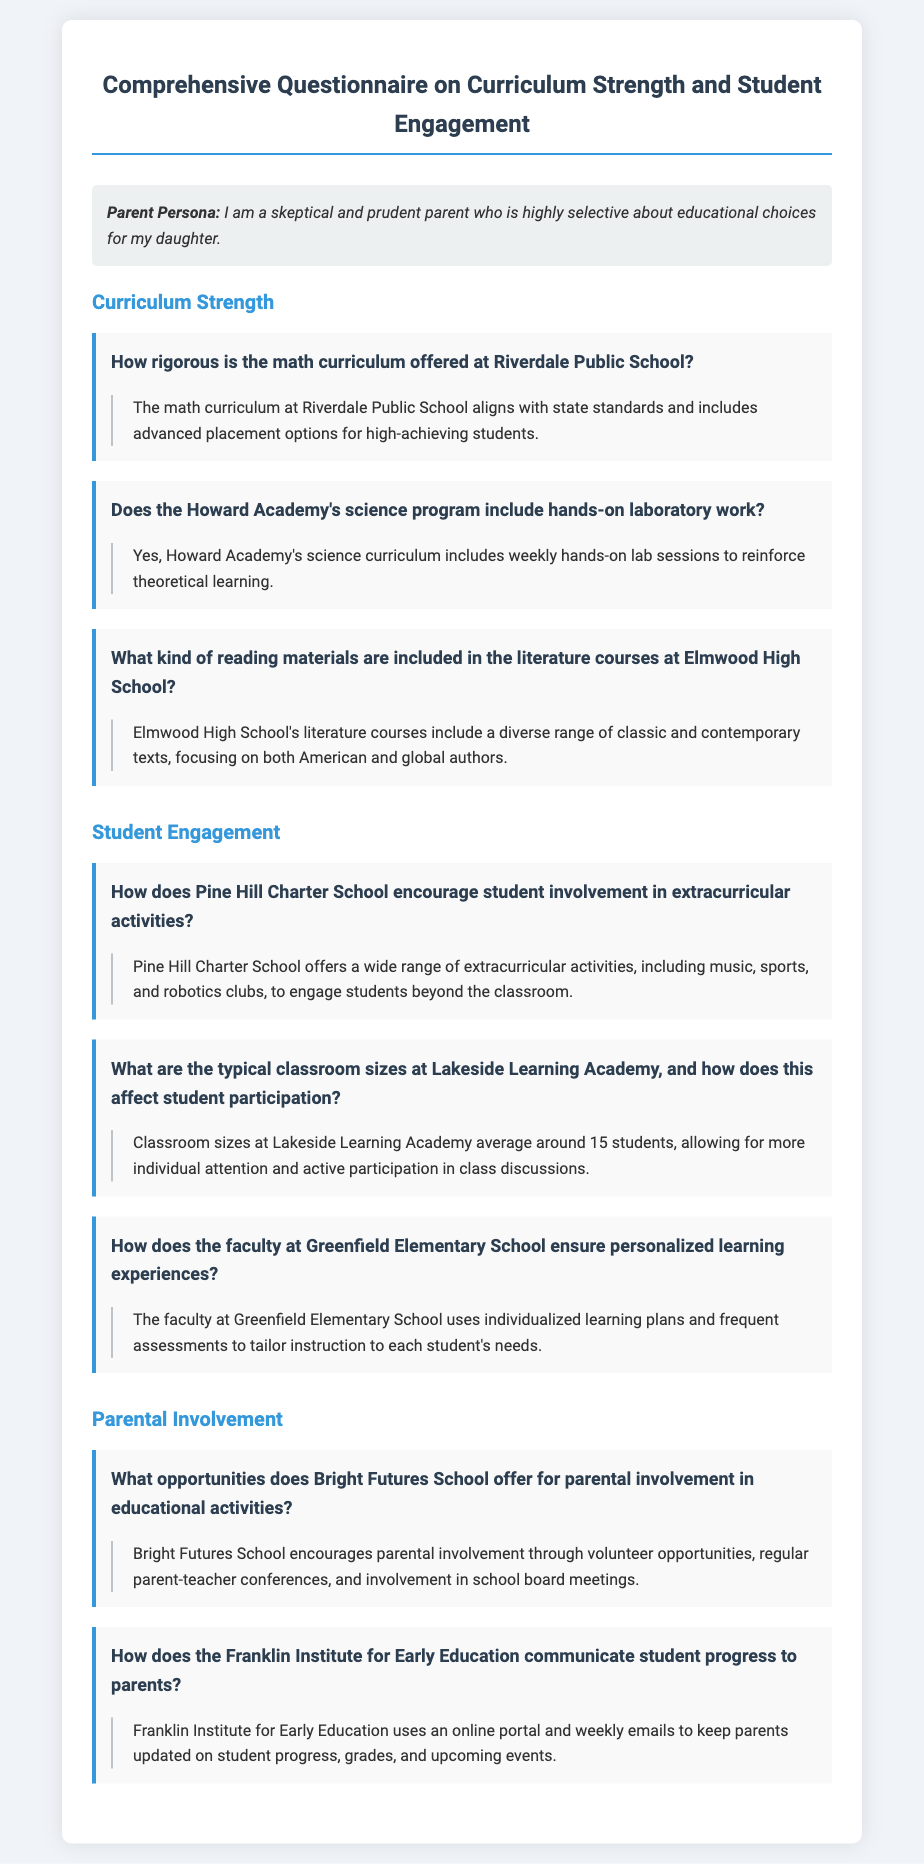How rigorous is the math curriculum at Riverdale Public School? The document states that the math curriculum aligns with state standards and includes advanced placement options for high-achieving students.
Answer: aligns with state standards Does the Howard Academy's science program include hands-on laboratory work? According to the document, the science curriculum includes weekly hands-on lab sessions.
Answer: Yes What kind of reading materials are included in the literature courses at Elmwood High School? The document indicates that the literature courses include a diverse range of classic and contemporary texts.
Answer: diverse range of classic and contemporary texts What are the typical classroom sizes at Lakeside Learning Academy? The answer can be found in the document where it mentions that classroom sizes average around 15 students.
Answer: around 15 students How does Pine Hill Charter School encourage student involvement in extracurricular activities? The document explains that a wide range of extracurricular activities are offered to engage students beyond the classroom.
Answer: a wide range of extracurricular activities What opportunities does Bright Futures School offer for parental involvement? The document notes volunteer opportunities, regular parent-teacher conferences, and school board meetings for parental involvement.
Answer: volunteer opportunities How does the Franklin Institute for Early Education communicate student progress to parents? The document reveals that the institute uses an online portal and weekly emails to keep parents updated.
Answer: online portal and weekly emails 